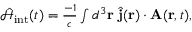<formula> <loc_0><loc_0><loc_500><loc_500>\begin{array} { r } { \hat { \mathcal { H } } _ { i n t } ( t ) = \frac { - 1 } { c } \int d ^ { 3 } { r } \, \hat { j } ( { r } ) \cdot { A } ( { r } , t ) , } \end{array}</formula> 